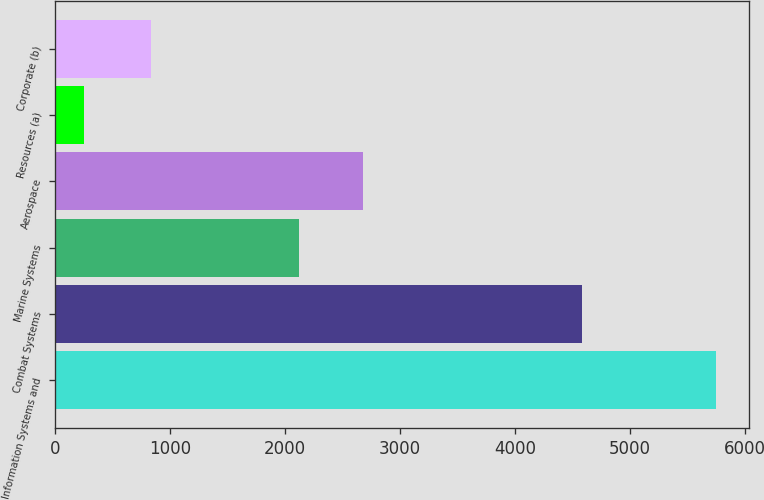Convert chart to OTSL. <chart><loc_0><loc_0><loc_500><loc_500><bar_chart><fcel>Information Systems and<fcel>Combat Systems<fcel>Marine Systems<fcel>Aerospace<fcel>Resources (a)<fcel>Corporate (b)<nl><fcel>5747<fcel>4588<fcel>2126<fcel>2675.2<fcel>255<fcel>832<nl></chart> 